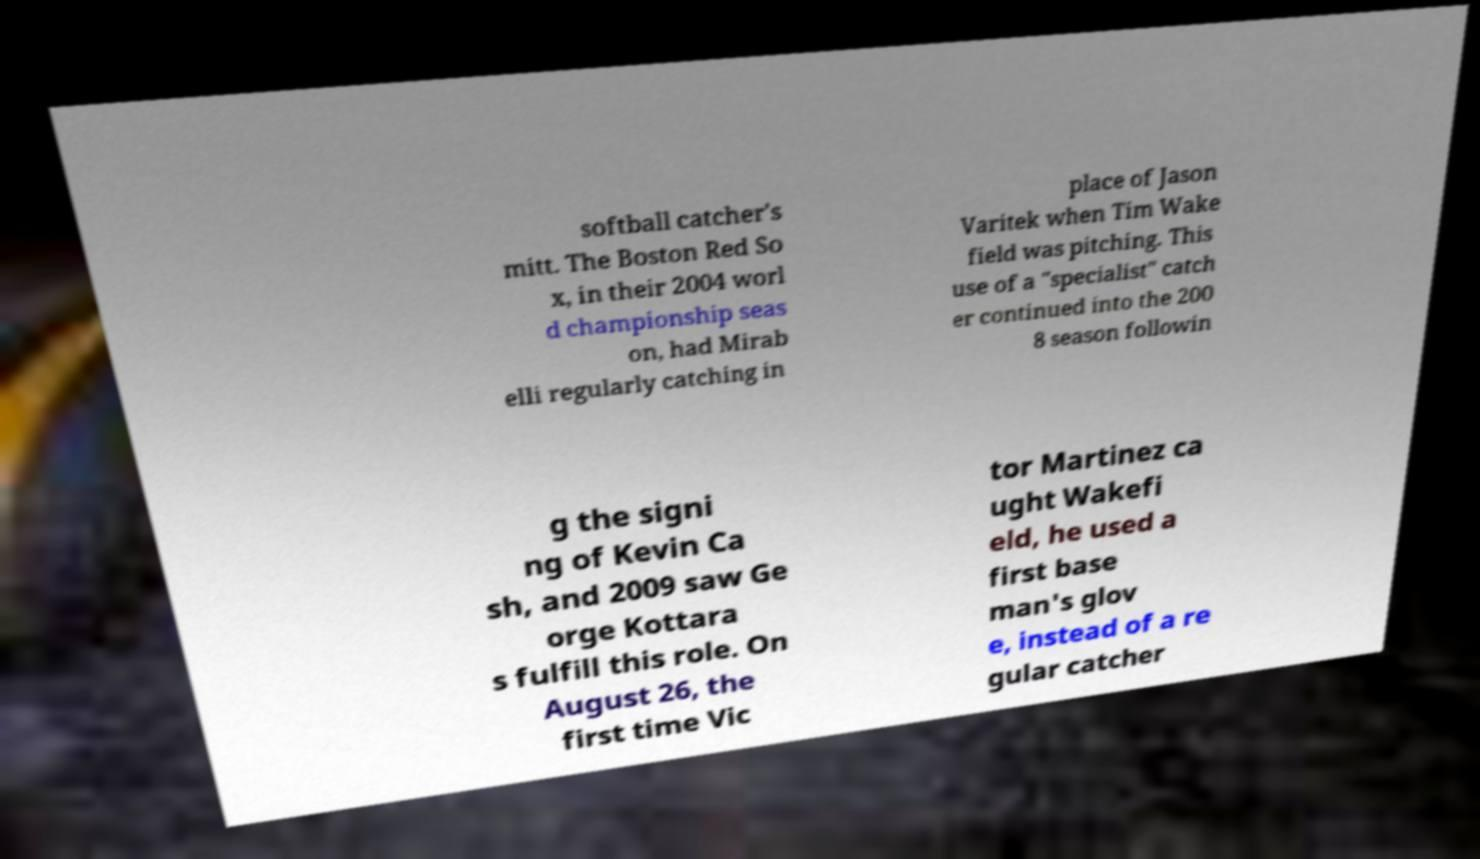Can you accurately transcribe the text from the provided image for me? softball catcher's mitt. The Boston Red So x, in their 2004 worl d championship seas on, had Mirab elli regularly catching in place of Jason Varitek when Tim Wake field was pitching. This use of a "specialist" catch er continued into the 200 8 season followin g the signi ng of Kevin Ca sh, and 2009 saw Ge orge Kottara s fulfill this role. On August 26, the first time Vic tor Martinez ca ught Wakefi eld, he used a first base man's glov e, instead of a re gular catcher 